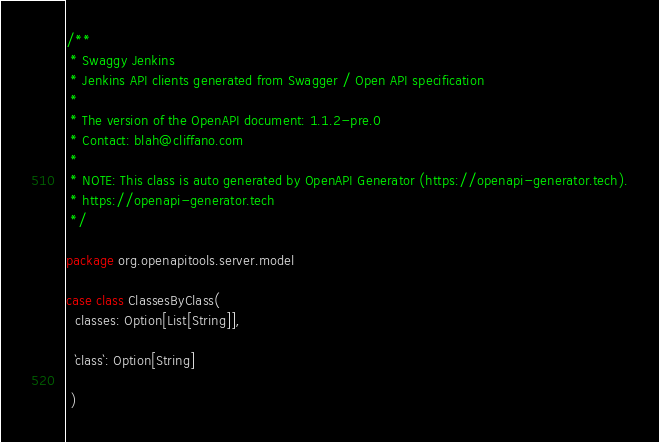Convert code to text. <code><loc_0><loc_0><loc_500><loc_500><_Scala_>/**
 * Swaggy Jenkins
 * Jenkins API clients generated from Swagger / Open API specification
 *
 * The version of the OpenAPI document: 1.1.2-pre.0
 * Contact: blah@cliffano.com
 *
 * NOTE: This class is auto generated by OpenAPI Generator (https://openapi-generator.tech).
 * https://openapi-generator.tech
 */

package org.openapitools.server.model

case class ClassesByClass(
  classes: Option[List[String]],

  `class`: Option[String]

 )
</code> 